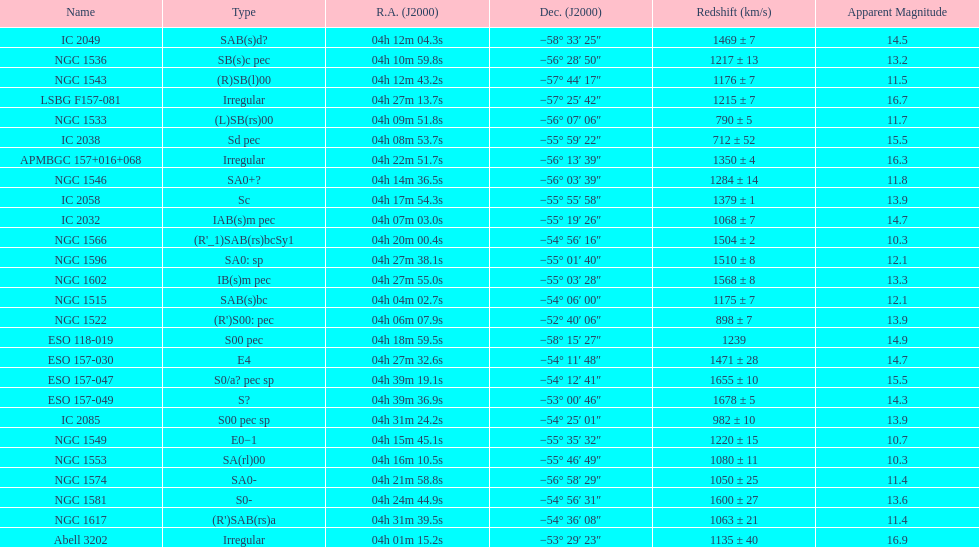Identify the member with the greatest apparent brightness. Abell 3202. 